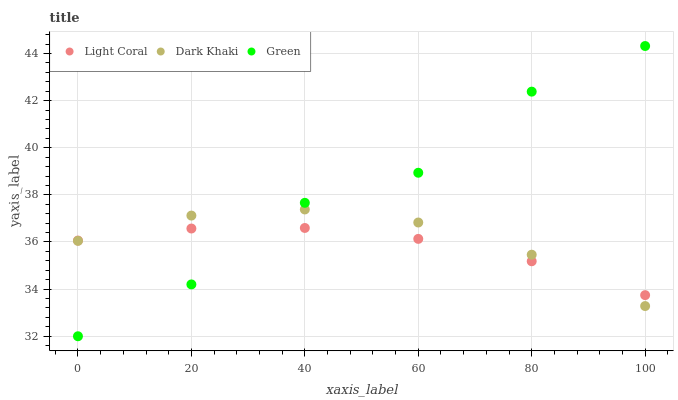Does Light Coral have the minimum area under the curve?
Answer yes or no. Yes. Does Green have the maximum area under the curve?
Answer yes or no. Yes. Does Dark Khaki have the minimum area under the curve?
Answer yes or no. No. Does Dark Khaki have the maximum area under the curve?
Answer yes or no. No. Is Light Coral the smoothest?
Answer yes or no. Yes. Is Green the roughest?
Answer yes or no. Yes. Is Dark Khaki the smoothest?
Answer yes or no. No. Is Dark Khaki the roughest?
Answer yes or no. No. Does Green have the lowest value?
Answer yes or no. Yes. Does Dark Khaki have the lowest value?
Answer yes or no. No. Does Green have the highest value?
Answer yes or no. Yes. Does Dark Khaki have the highest value?
Answer yes or no. No. Does Light Coral intersect Dark Khaki?
Answer yes or no. Yes. Is Light Coral less than Dark Khaki?
Answer yes or no. No. Is Light Coral greater than Dark Khaki?
Answer yes or no. No. 